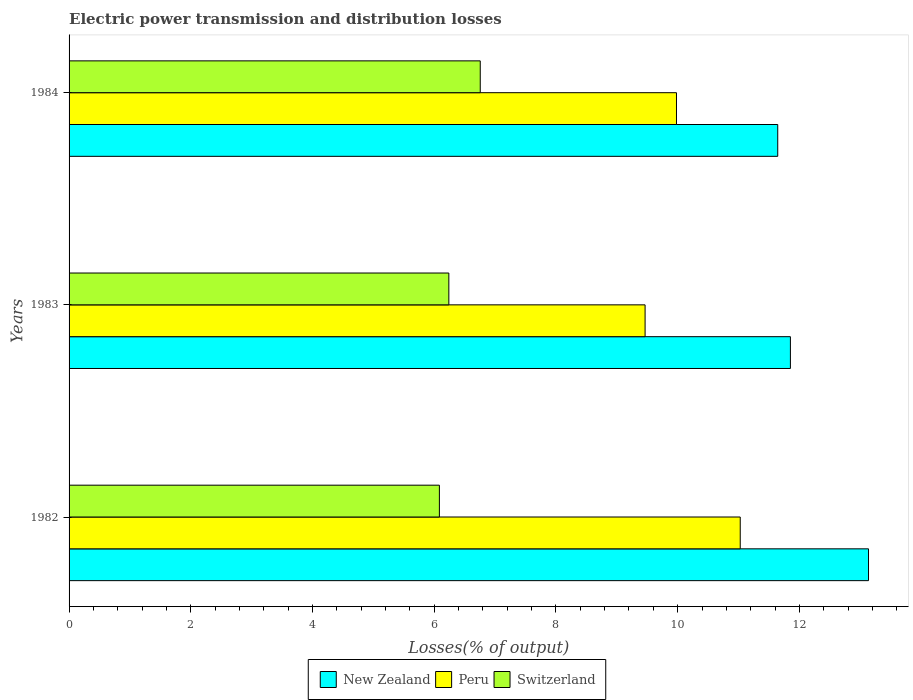How many bars are there on the 1st tick from the bottom?
Keep it short and to the point. 3. What is the label of the 3rd group of bars from the top?
Your response must be concise. 1982. What is the electric power transmission and distribution losses in New Zealand in 1984?
Provide a short and direct response. 11.64. Across all years, what is the maximum electric power transmission and distribution losses in Peru?
Your response must be concise. 11.03. Across all years, what is the minimum electric power transmission and distribution losses in Peru?
Offer a very short reply. 9.46. In which year was the electric power transmission and distribution losses in Switzerland minimum?
Give a very brief answer. 1982. What is the total electric power transmission and distribution losses in Peru in the graph?
Your response must be concise. 30.47. What is the difference between the electric power transmission and distribution losses in Switzerland in 1982 and that in 1984?
Give a very brief answer. -0.67. What is the difference between the electric power transmission and distribution losses in New Zealand in 1984 and the electric power transmission and distribution losses in Switzerland in 1982?
Make the answer very short. 5.56. What is the average electric power transmission and distribution losses in New Zealand per year?
Provide a succinct answer. 12.21. In the year 1982, what is the difference between the electric power transmission and distribution losses in Switzerland and electric power transmission and distribution losses in Peru?
Offer a terse response. -4.94. What is the ratio of the electric power transmission and distribution losses in New Zealand in 1982 to that in 1983?
Provide a short and direct response. 1.11. What is the difference between the highest and the second highest electric power transmission and distribution losses in New Zealand?
Your response must be concise. 1.28. What is the difference between the highest and the lowest electric power transmission and distribution losses in Peru?
Keep it short and to the point. 1.56. Is the sum of the electric power transmission and distribution losses in New Zealand in 1982 and 1984 greater than the maximum electric power transmission and distribution losses in Peru across all years?
Your response must be concise. Yes. What does the 1st bar from the bottom in 1982 represents?
Offer a terse response. New Zealand. How many years are there in the graph?
Give a very brief answer. 3. Are the values on the major ticks of X-axis written in scientific E-notation?
Your answer should be very brief. No. Does the graph contain grids?
Give a very brief answer. No. How many legend labels are there?
Make the answer very short. 3. How are the legend labels stacked?
Your response must be concise. Horizontal. What is the title of the graph?
Your answer should be very brief. Electric power transmission and distribution losses. Does "Georgia" appear as one of the legend labels in the graph?
Give a very brief answer. No. What is the label or title of the X-axis?
Make the answer very short. Losses(% of output). What is the Losses(% of output) of New Zealand in 1982?
Offer a terse response. 13.14. What is the Losses(% of output) in Peru in 1982?
Give a very brief answer. 11.03. What is the Losses(% of output) of Switzerland in 1982?
Ensure brevity in your answer.  6.08. What is the Losses(% of output) in New Zealand in 1983?
Keep it short and to the point. 11.85. What is the Losses(% of output) in Peru in 1983?
Give a very brief answer. 9.46. What is the Losses(% of output) in Switzerland in 1983?
Make the answer very short. 6.24. What is the Losses(% of output) in New Zealand in 1984?
Your response must be concise. 11.64. What is the Losses(% of output) in Peru in 1984?
Offer a terse response. 9.98. What is the Losses(% of output) of Switzerland in 1984?
Give a very brief answer. 6.76. Across all years, what is the maximum Losses(% of output) in New Zealand?
Give a very brief answer. 13.14. Across all years, what is the maximum Losses(% of output) in Peru?
Give a very brief answer. 11.03. Across all years, what is the maximum Losses(% of output) in Switzerland?
Give a very brief answer. 6.76. Across all years, what is the minimum Losses(% of output) in New Zealand?
Provide a succinct answer. 11.64. Across all years, what is the minimum Losses(% of output) in Peru?
Offer a terse response. 9.46. Across all years, what is the minimum Losses(% of output) of Switzerland?
Ensure brevity in your answer.  6.08. What is the total Losses(% of output) in New Zealand in the graph?
Provide a short and direct response. 36.63. What is the total Losses(% of output) in Peru in the graph?
Your answer should be compact. 30.47. What is the total Losses(% of output) in Switzerland in the graph?
Provide a short and direct response. 19.08. What is the difference between the Losses(% of output) in New Zealand in 1982 and that in 1983?
Your answer should be very brief. 1.28. What is the difference between the Losses(% of output) of Peru in 1982 and that in 1983?
Your response must be concise. 1.56. What is the difference between the Losses(% of output) in Switzerland in 1982 and that in 1983?
Give a very brief answer. -0.16. What is the difference between the Losses(% of output) of New Zealand in 1982 and that in 1984?
Provide a succinct answer. 1.49. What is the difference between the Losses(% of output) in Peru in 1982 and that in 1984?
Give a very brief answer. 1.05. What is the difference between the Losses(% of output) in Switzerland in 1982 and that in 1984?
Offer a terse response. -0.67. What is the difference between the Losses(% of output) of New Zealand in 1983 and that in 1984?
Your answer should be very brief. 0.21. What is the difference between the Losses(% of output) of Peru in 1983 and that in 1984?
Make the answer very short. -0.52. What is the difference between the Losses(% of output) in Switzerland in 1983 and that in 1984?
Provide a succinct answer. -0.52. What is the difference between the Losses(% of output) of New Zealand in 1982 and the Losses(% of output) of Peru in 1983?
Provide a succinct answer. 3.67. What is the difference between the Losses(% of output) of New Zealand in 1982 and the Losses(% of output) of Switzerland in 1983?
Give a very brief answer. 6.9. What is the difference between the Losses(% of output) in Peru in 1982 and the Losses(% of output) in Switzerland in 1983?
Provide a succinct answer. 4.79. What is the difference between the Losses(% of output) of New Zealand in 1982 and the Losses(% of output) of Peru in 1984?
Provide a succinct answer. 3.16. What is the difference between the Losses(% of output) of New Zealand in 1982 and the Losses(% of output) of Switzerland in 1984?
Your answer should be very brief. 6.38. What is the difference between the Losses(% of output) in Peru in 1982 and the Losses(% of output) in Switzerland in 1984?
Provide a short and direct response. 4.27. What is the difference between the Losses(% of output) of New Zealand in 1983 and the Losses(% of output) of Peru in 1984?
Your answer should be compact. 1.87. What is the difference between the Losses(% of output) in New Zealand in 1983 and the Losses(% of output) in Switzerland in 1984?
Your response must be concise. 5.1. What is the difference between the Losses(% of output) in Peru in 1983 and the Losses(% of output) in Switzerland in 1984?
Make the answer very short. 2.71. What is the average Losses(% of output) of New Zealand per year?
Your answer should be very brief. 12.21. What is the average Losses(% of output) of Peru per year?
Provide a succinct answer. 10.16. What is the average Losses(% of output) in Switzerland per year?
Ensure brevity in your answer.  6.36. In the year 1982, what is the difference between the Losses(% of output) of New Zealand and Losses(% of output) of Peru?
Your answer should be compact. 2.11. In the year 1982, what is the difference between the Losses(% of output) in New Zealand and Losses(% of output) in Switzerland?
Ensure brevity in your answer.  7.05. In the year 1982, what is the difference between the Losses(% of output) of Peru and Losses(% of output) of Switzerland?
Make the answer very short. 4.94. In the year 1983, what is the difference between the Losses(% of output) in New Zealand and Losses(% of output) in Peru?
Keep it short and to the point. 2.39. In the year 1983, what is the difference between the Losses(% of output) in New Zealand and Losses(% of output) in Switzerland?
Ensure brevity in your answer.  5.61. In the year 1983, what is the difference between the Losses(% of output) in Peru and Losses(% of output) in Switzerland?
Provide a short and direct response. 3.22. In the year 1984, what is the difference between the Losses(% of output) in New Zealand and Losses(% of output) in Peru?
Your answer should be very brief. 1.66. In the year 1984, what is the difference between the Losses(% of output) of New Zealand and Losses(% of output) of Switzerland?
Make the answer very short. 4.89. In the year 1984, what is the difference between the Losses(% of output) in Peru and Losses(% of output) in Switzerland?
Offer a terse response. 3.22. What is the ratio of the Losses(% of output) of New Zealand in 1982 to that in 1983?
Your response must be concise. 1.11. What is the ratio of the Losses(% of output) in Peru in 1982 to that in 1983?
Make the answer very short. 1.17. What is the ratio of the Losses(% of output) of Switzerland in 1982 to that in 1983?
Keep it short and to the point. 0.98. What is the ratio of the Losses(% of output) of New Zealand in 1982 to that in 1984?
Give a very brief answer. 1.13. What is the ratio of the Losses(% of output) of Peru in 1982 to that in 1984?
Give a very brief answer. 1.1. What is the ratio of the Losses(% of output) of Switzerland in 1982 to that in 1984?
Ensure brevity in your answer.  0.9. What is the ratio of the Losses(% of output) in New Zealand in 1983 to that in 1984?
Keep it short and to the point. 1.02. What is the ratio of the Losses(% of output) of Peru in 1983 to that in 1984?
Offer a very short reply. 0.95. What is the ratio of the Losses(% of output) in Switzerland in 1983 to that in 1984?
Keep it short and to the point. 0.92. What is the difference between the highest and the second highest Losses(% of output) in New Zealand?
Your response must be concise. 1.28. What is the difference between the highest and the second highest Losses(% of output) in Peru?
Ensure brevity in your answer.  1.05. What is the difference between the highest and the second highest Losses(% of output) of Switzerland?
Ensure brevity in your answer.  0.52. What is the difference between the highest and the lowest Losses(% of output) of New Zealand?
Provide a short and direct response. 1.49. What is the difference between the highest and the lowest Losses(% of output) of Peru?
Your answer should be very brief. 1.56. What is the difference between the highest and the lowest Losses(% of output) in Switzerland?
Give a very brief answer. 0.67. 